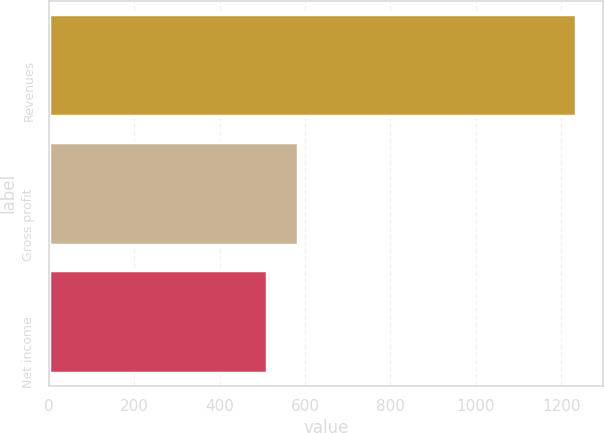<chart> <loc_0><loc_0><loc_500><loc_500><bar_chart><fcel>Revenues<fcel>Gross profit<fcel>Net income<nl><fcel>1235<fcel>584.3<fcel>512<nl></chart> 